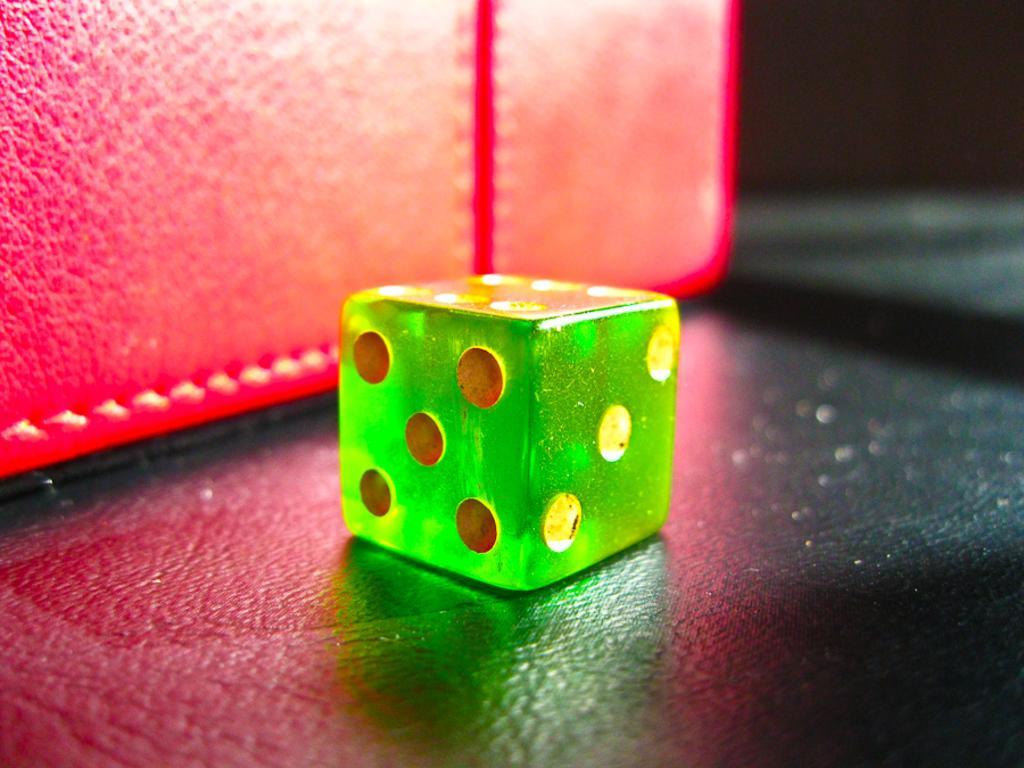What object is the main subject of the image? There is a dice in the image. What is the color of the dice? The dice is green in color. What is the color of the mat in the image? There is a red color mat in the image. Can you see the chin of the person rolling the dice in the image? There is no person present in the image, so it is not possible to see their chin. 